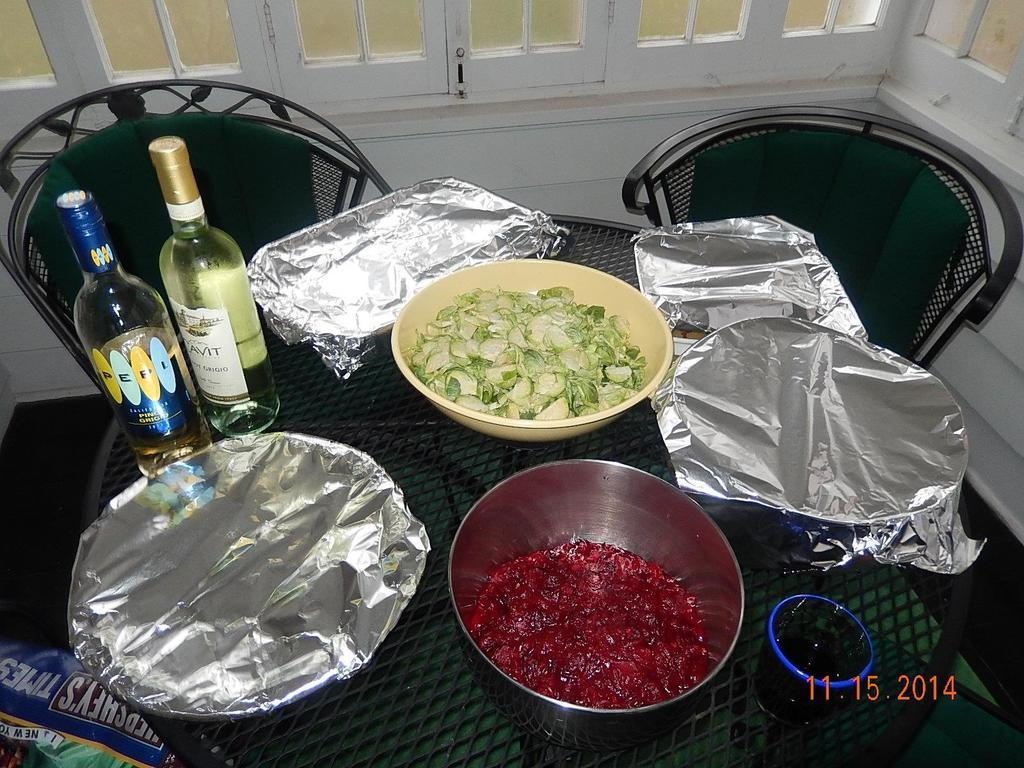What type of table is in the image? There is a metal table in the image. How many bowls are on the table? There are two bowls on the table. What else is on the table besides the bowls? There are two wine bottles, a food covered with a cover, and a glass on the table. Is there any seating in the image? Yes, there is a chair in the image. What can be seen through the window in the image? The facts provided do not mention what can be seen through the window. What type of drug is being served on the plate in the image? There is no plate or drug present in the image. What is the interest rate of the loan mentioned in the image? There is no mention of a loan or interest rate in the image. 